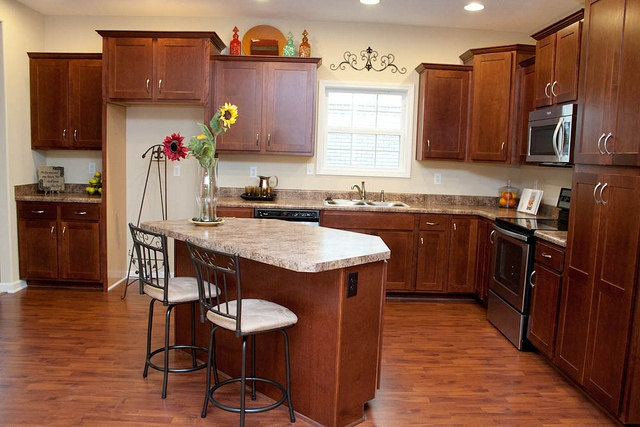Describe the objects in this image and their specific colors. I can see dining table in tan, maroon, and lightgray tones, chair in tan, black, maroon, lightgray, and darkgray tones, chair in tan, black, maroon, darkgray, and brown tones, oven in tan, black, maroon, and gray tones, and potted plant in tan, darkgray, olive, and gray tones in this image. 